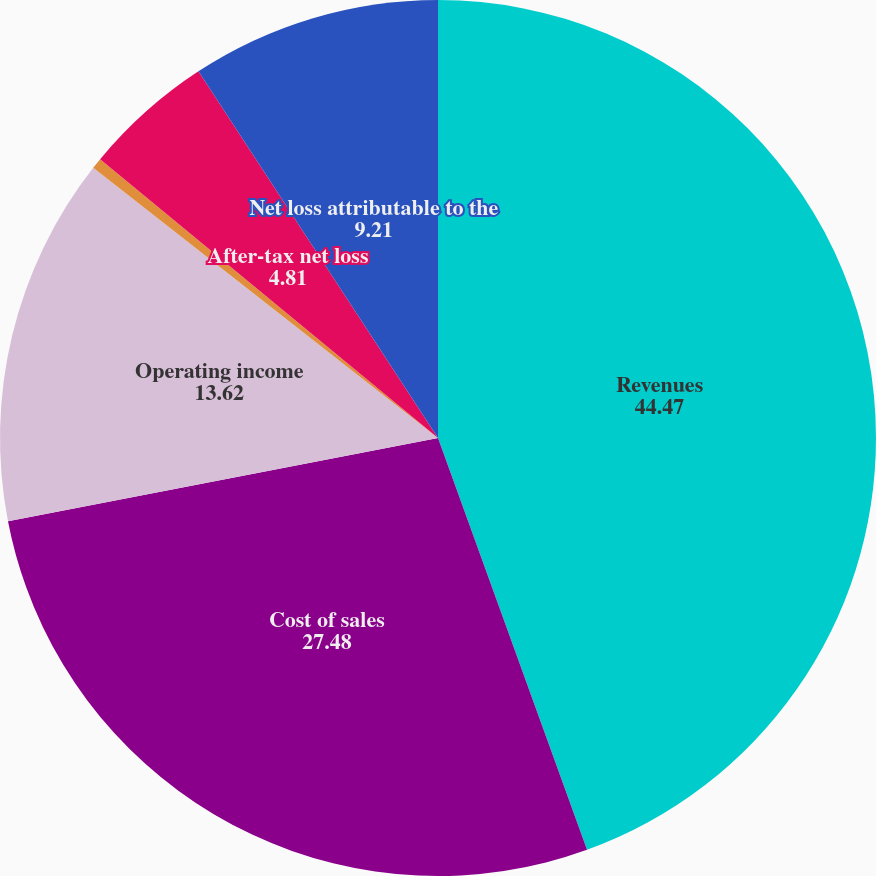Convert chart to OTSL. <chart><loc_0><loc_0><loc_500><loc_500><pie_chart><fcel>Revenues<fcel>Cost of sales<fcel>Operating income<fcel>Pre-tax income (loss) from<fcel>After-tax net loss<fcel>Net loss attributable to the<nl><fcel>44.47%<fcel>27.48%<fcel>13.62%<fcel>0.4%<fcel>4.81%<fcel>9.21%<nl></chart> 